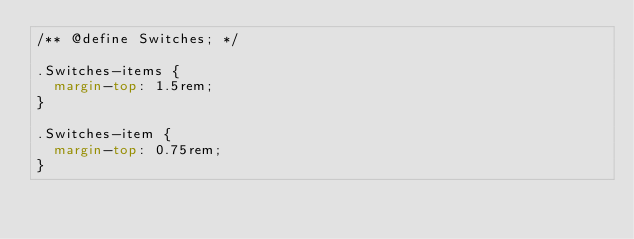Convert code to text. <code><loc_0><loc_0><loc_500><loc_500><_CSS_>/** @define Switches; */

.Switches-items {
  margin-top: 1.5rem;
}

.Switches-item {
  margin-top: 0.75rem;
}
</code> 